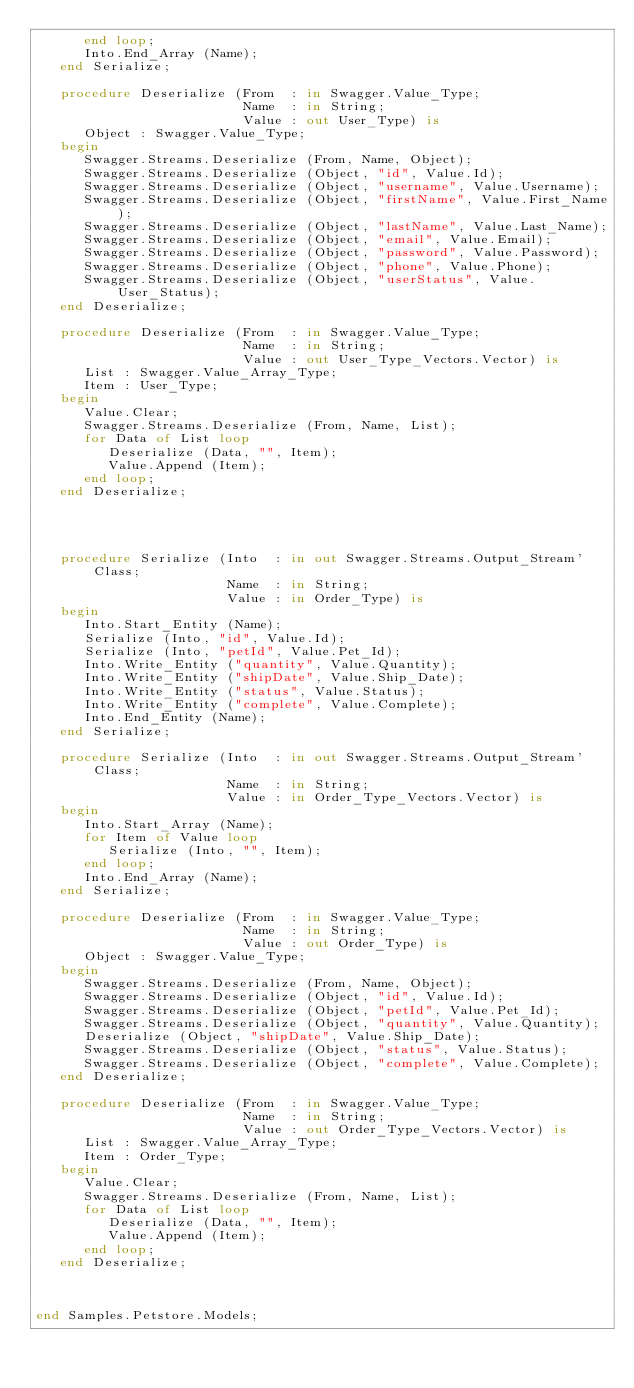Convert code to text. <code><loc_0><loc_0><loc_500><loc_500><_Ada_>      end loop;
      Into.End_Array (Name);
   end Serialize;

   procedure Deserialize (From  : in Swagger.Value_Type;
                          Name  : in String;
                          Value : out User_Type) is
      Object : Swagger.Value_Type;
   begin
      Swagger.Streams.Deserialize (From, Name, Object);
      Swagger.Streams.Deserialize (Object, "id", Value.Id);
      Swagger.Streams.Deserialize (Object, "username", Value.Username);
      Swagger.Streams.Deserialize (Object, "firstName", Value.First_Name);
      Swagger.Streams.Deserialize (Object, "lastName", Value.Last_Name);
      Swagger.Streams.Deserialize (Object, "email", Value.Email);
      Swagger.Streams.Deserialize (Object, "password", Value.Password);
      Swagger.Streams.Deserialize (Object, "phone", Value.Phone);
      Swagger.Streams.Deserialize (Object, "userStatus", Value.User_Status);
   end Deserialize;

   procedure Deserialize (From  : in Swagger.Value_Type;
                          Name  : in String;
                          Value : out User_Type_Vectors.Vector) is
      List : Swagger.Value_Array_Type;
      Item : User_Type;
   begin
      Value.Clear;
      Swagger.Streams.Deserialize (From, Name, List);
      for Data of List loop
         Deserialize (Data, "", Item);
         Value.Append (Item);
      end loop;
   end Deserialize;




   procedure Serialize (Into  : in out Swagger.Streams.Output_Stream'Class;
                        Name  : in String;
                        Value : in Order_Type) is
   begin
      Into.Start_Entity (Name);
      Serialize (Into, "id", Value.Id);
      Serialize (Into, "petId", Value.Pet_Id);
      Into.Write_Entity ("quantity", Value.Quantity);
      Into.Write_Entity ("shipDate", Value.Ship_Date);
      Into.Write_Entity ("status", Value.Status);
      Into.Write_Entity ("complete", Value.Complete);
      Into.End_Entity (Name);
   end Serialize;

   procedure Serialize (Into  : in out Swagger.Streams.Output_Stream'Class;
                        Name  : in String;
                        Value : in Order_Type_Vectors.Vector) is
   begin
      Into.Start_Array (Name);
      for Item of Value loop
         Serialize (Into, "", Item);
      end loop;
      Into.End_Array (Name);
   end Serialize;

   procedure Deserialize (From  : in Swagger.Value_Type;
                          Name  : in String;
                          Value : out Order_Type) is
      Object : Swagger.Value_Type;
   begin
      Swagger.Streams.Deserialize (From, Name, Object);
      Swagger.Streams.Deserialize (Object, "id", Value.Id);
      Swagger.Streams.Deserialize (Object, "petId", Value.Pet_Id);
      Swagger.Streams.Deserialize (Object, "quantity", Value.Quantity);
      Deserialize (Object, "shipDate", Value.Ship_Date);
      Swagger.Streams.Deserialize (Object, "status", Value.Status);
      Swagger.Streams.Deserialize (Object, "complete", Value.Complete);
   end Deserialize;

   procedure Deserialize (From  : in Swagger.Value_Type;
                          Name  : in String;
                          Value : out Order_Type_Vectors.Vector) is
      List : Swagger.Value_Array_Type;
      Item : Order_Type;
   begin
      Value.Clear;
      Swagger.Streams.Deserialize (From, Name, List);
      for Data of List loop
         Deserialize (Data, "", Item);
         Value.Append (Item);
      end loop;
   end Deserialize;



end Samples.Petstore.Models;
</code> 